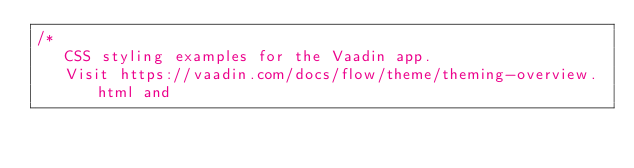<code> <loc_0><loc_0><loc_500><loc_500><_CSS_>/*
   CSS styling examples for the Vaadin app.
   Visit https://vaadin.com/docs/flow/theme/theming-overview.html and</code> 